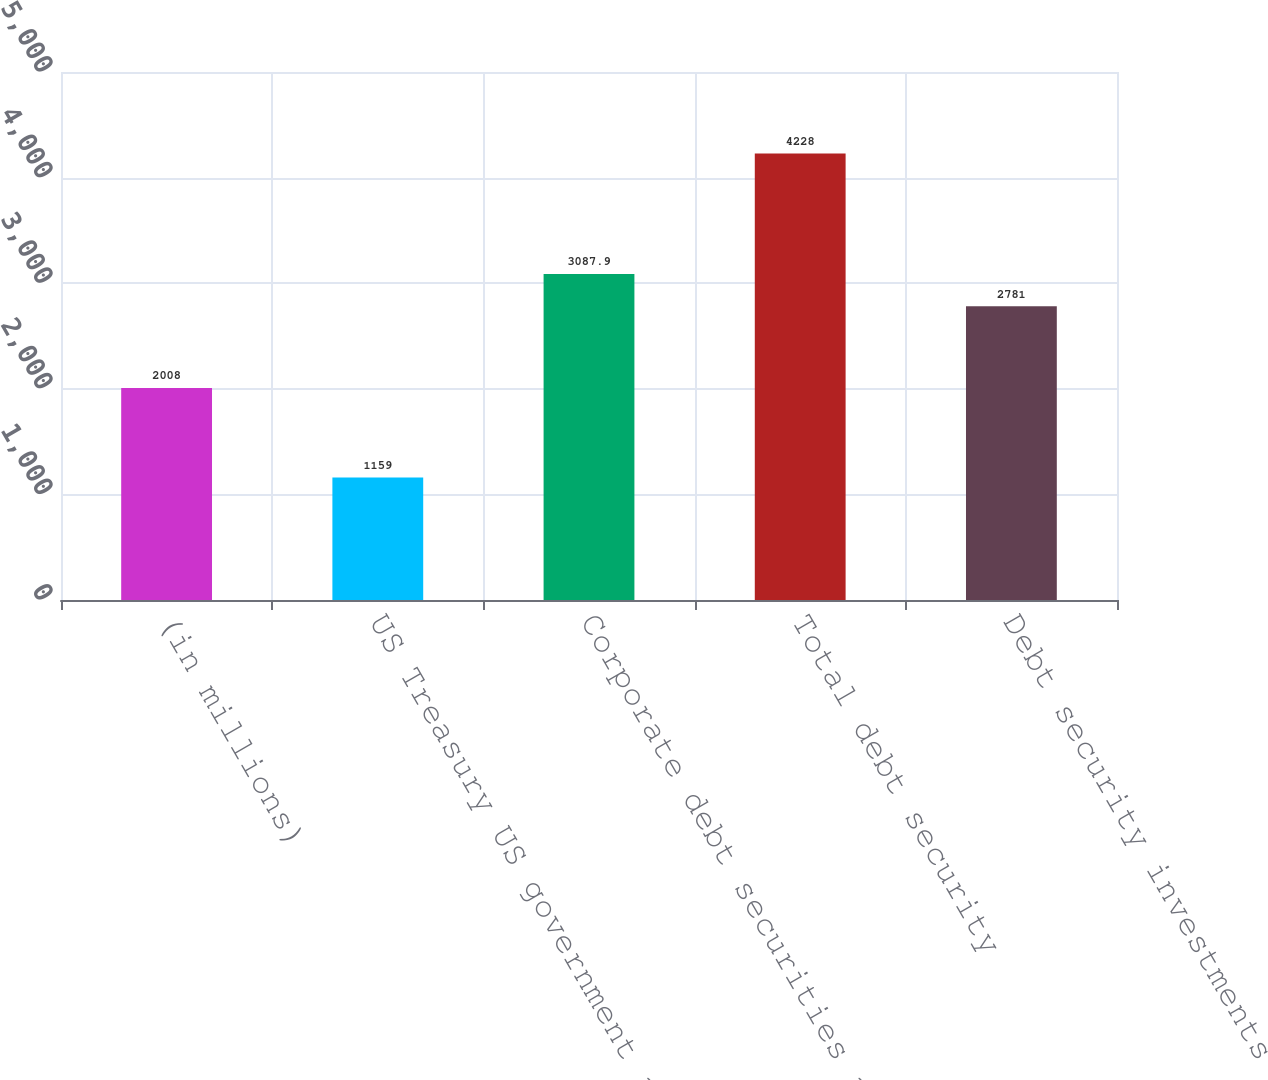Convert chart. <chart><loc_0><loc_0><loc_500><loc_500><bar_chart><fcel>(in millions)<fcel>US Treasury US government and<fcel>Corporate debt securities and<fcel>Total debt security<fcel>Debt security investments<nl><fcel>2008<fcel>1159<fcel>3087.9<fcel>4228<fcel>2781<nl></chart> 